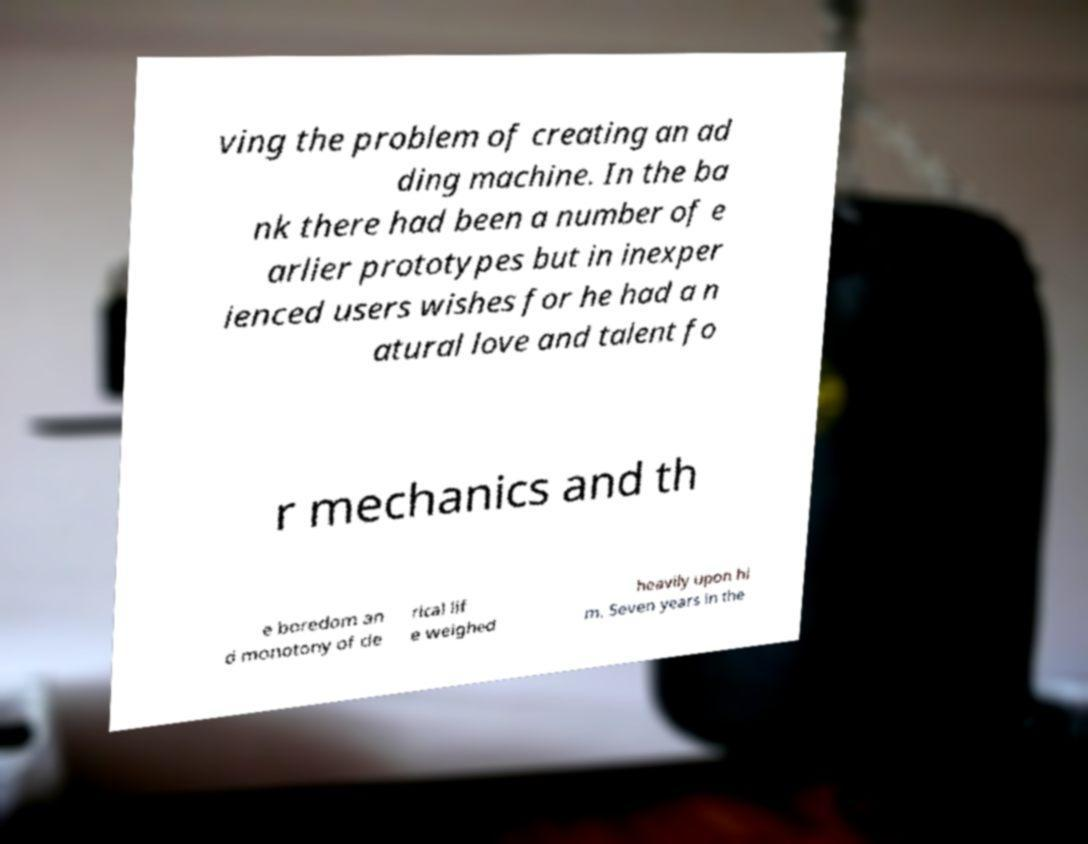Could you assist in decoding the text presented in this image and type it out clearly? ving the problem of creating an ad ding machine. In the ba nk there had been a number of e arlier prototypes but in inexper ienced users wishes for he had a n atural love and talent fo r mechanics and th e boredom an d monotony of cle rical lif e weighed heavily upon hi m. Seven years in the 